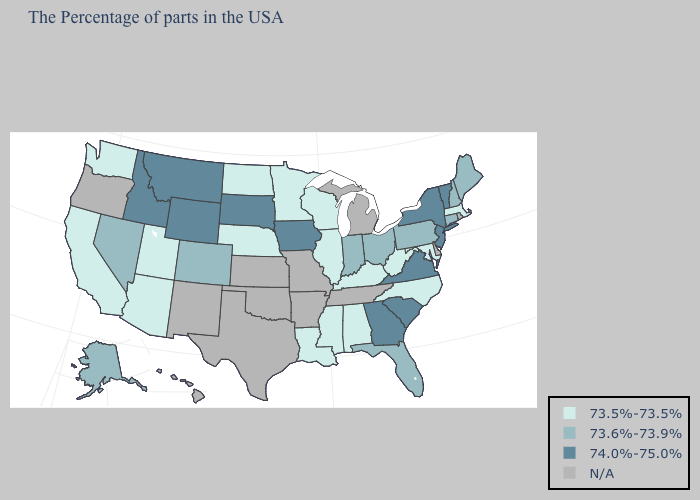Does South Dakota have the highest value in the MidWest?
Keep it brief. Yes. Which states have the highest value in the USA?
Be succinct. Vermont, New York, New Jersey, Virginia, South Carolina, Georgia, Iowa, South Dakota, Wyoming, Montana, Idaho. What is the value of Kansas?
Write a very short answer. N/A. Among the states that border Alabama , does Mississippi have the highest value?
Give a very brief answer. No. What is the value of Louisiana?
Write a very short answer. 73.5%-73.5%. Name the states that have a value in the range 74.0%-75.0%?
Concise answer only. Vermont, New York, New Jersey, Virginia, South Carolina, Georgia, Iowa, South Dakota, Wyoming, Montana, Idaho. Does Washington have the highest value in the USA?
Answer briefly. No. Which states hav the highest value in the West?
Be succinct. Wyoming, Montana, Idaho. What is the highest value in the USA?
Give a very brief answer. 74.0%-75.0%. Name the states that have a value in the range 73.5%-73.5%?
Quick response, please. Massachusetts, Maryland, North Carolina, West Virginia, Kentucky, Alabama, Wisconsin, Illinois, Mississippi, Louisiana, Minnesota, Nebraska, North Dakota, Utah, Arizona, California, Washington. Name the states that have a value in the range 73.6%-73.9%?
Keep it brief. Maine, New Hampshire, Connecticut, Pennsylvania, Ohio, Florida, Indiana, Colorado, Nevada, Alaska. Name the states that have a value in the range N/A?
Be succinct. Rhode Island, Delaware, Michigan, Tennessee, Missouri, Arkansas, Kansas, Oklahoma, Texas, New Mexico, Oregon, Hawaii. Which states hav the highest value in the Northeast?
Quick response, please. Vermont, New York, New Jersey. What is the lowest value in the USA?
Short answer required. 73.5%-73.5%. 